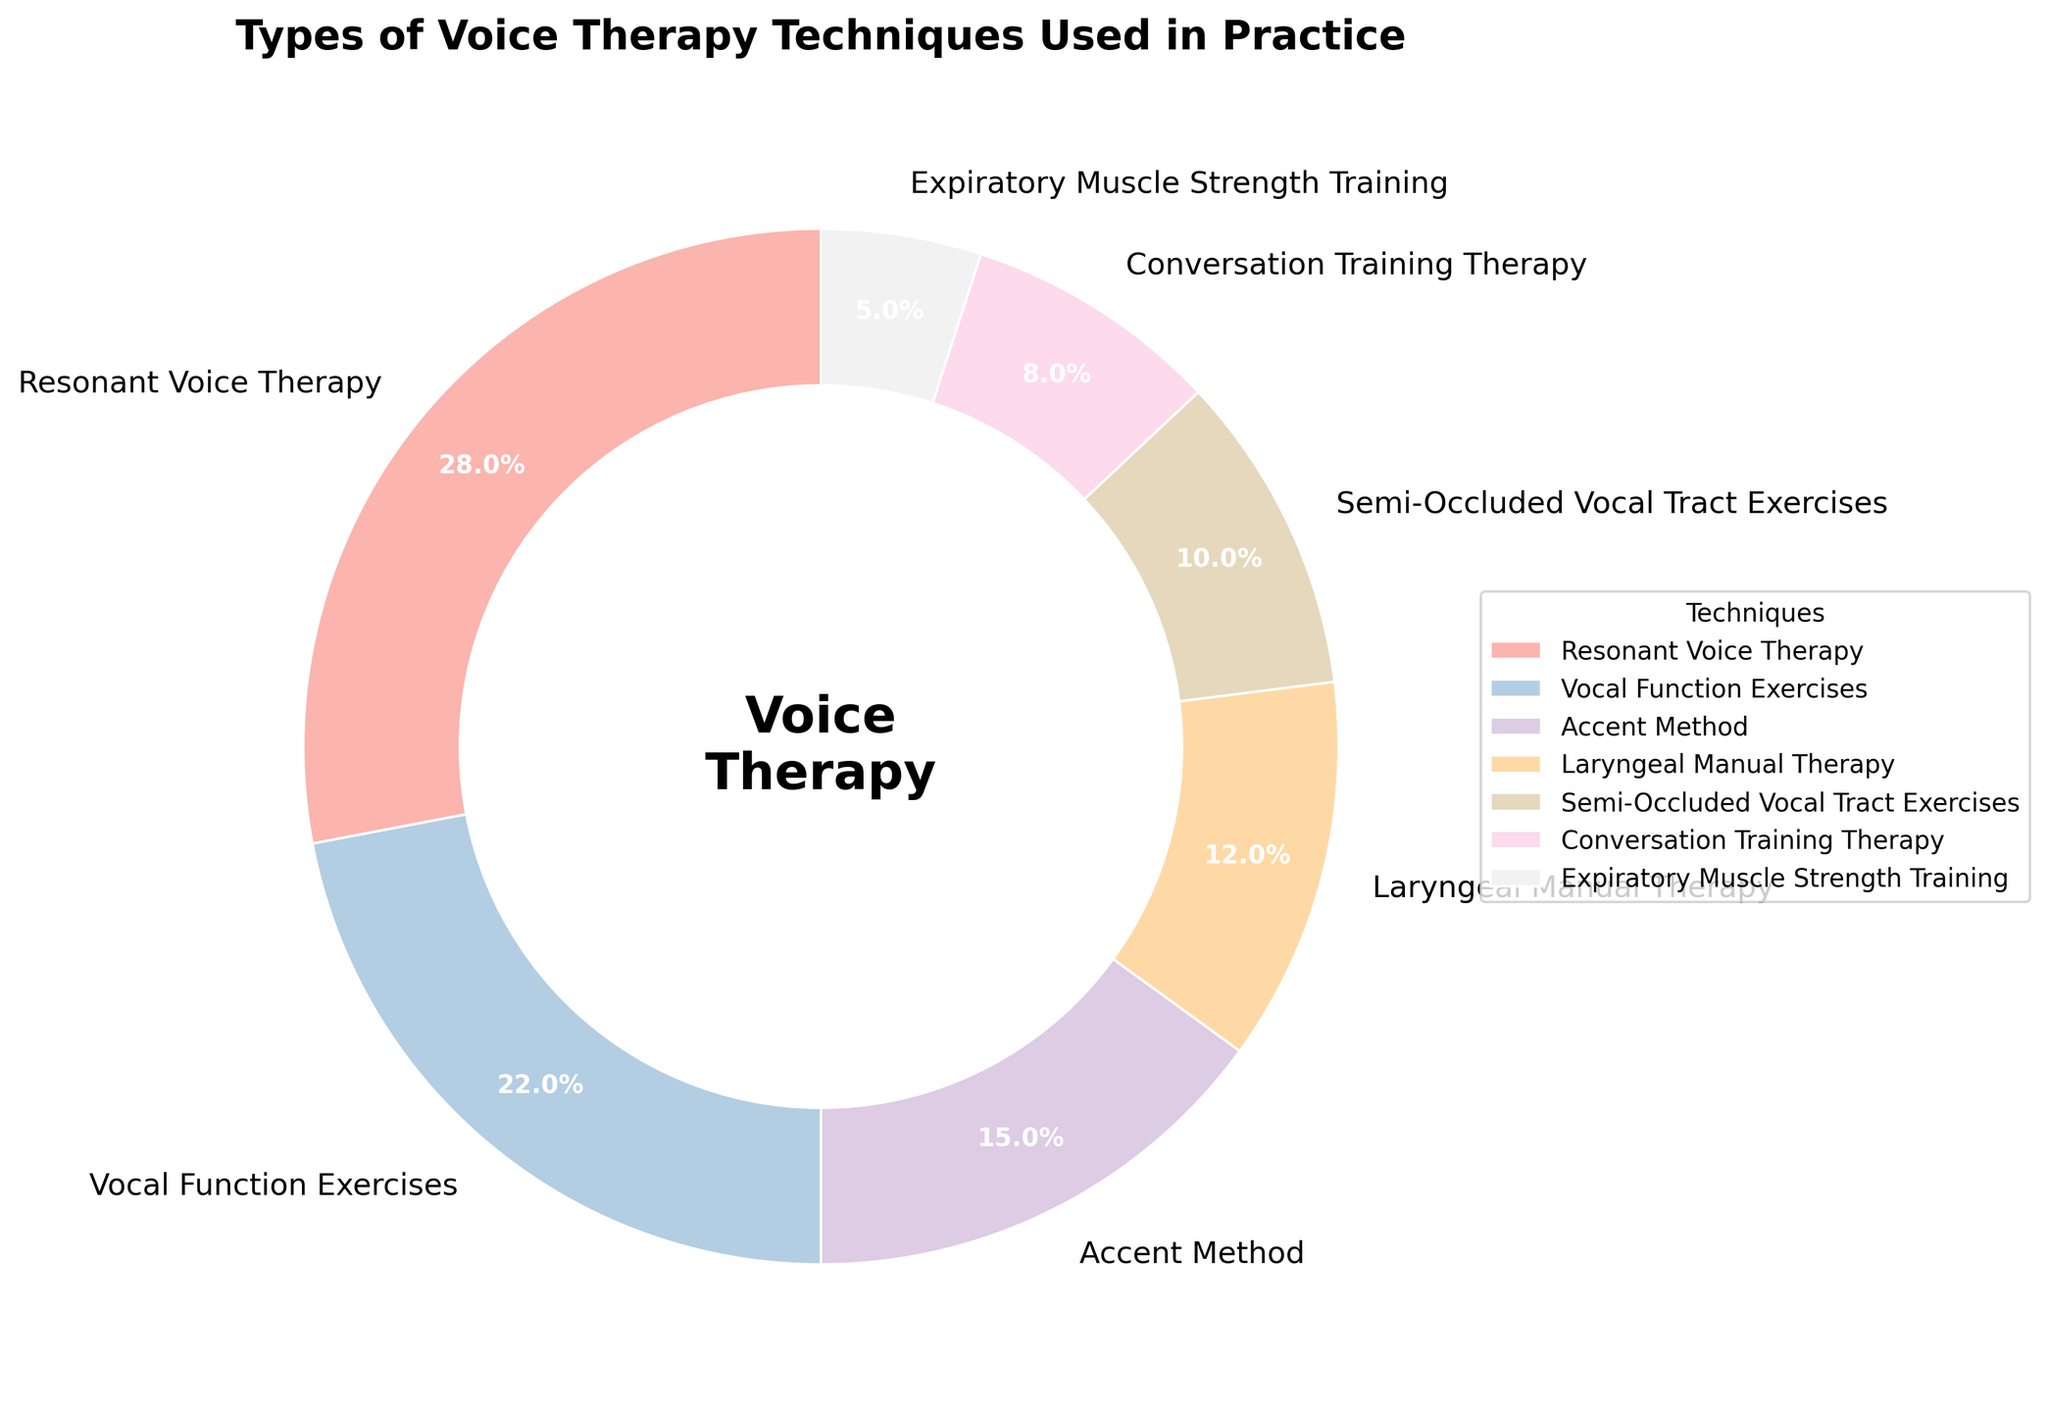What percentage of the techniques are accounted for by "Resonant Voice Therapy" and "Vocal Function Exercises" combined? "Resonant Voice Therapy" and "Vocal Function Exercises" are 28% and 22%, respectively. Summing these gives 28% + 22% = 50%.
Answer: 50% Which technique has the lowest percentage in the pie chart? By visually inspecting the slices, "Expiratory Muscle Strength Training" has the smallest slice. According to the data, its percentage is 5%.
Answer: Expiratory Muscle Strength Training Is the percentage for "Accent Method" greater than that for "Laryngeal Manual Therapy"? Comparing the slices visually, "Accent Method" (15%) is greater than "Laryngeal Manual Therapy" (12%).
Answer: Yes How much more common is "Semi-Occluded Vocal Tract Exercises" compared to "Expiratory Muscle Strength Training"? "Semi-Occluded Vocal Tract Exercises" is 10% and "Expiratory Muscle Strength Training" is 5%. Subtracting these percentages gives 10% - 5% = 5%.
Answer: 5% What is the approximate combined percentage of the three least common techniques? The three least common techniques are "Expiratory Muscle Strength Training" (5%), "Conversation Training Therapy" (8%), and "Semi-Occluded Vocal Tract Exercises" (10%). Adding these up gives 5% + 8% + 10% = 23%.
Answer: 23% Which technique occupies the largest portion of the pie chart? Visually, the largest slice belongs to "Resonant Voice Therapy," which is 28%.
Answer: Resonant Voice Therapy Compare the summed percentage of "Accent Method" and "Laryngeal Manual Therapy" to "Resonant Voice Therapy." "Accent Method" is 15% and "Laryngeal Manual Therapy" is 12%. Summing these gives 15% + 12% = 27%. "Resonant Voice Therapy" alone is 28%.
Answer: Less Is the section representing "Vocal Function Exercises" larger than that for "Accent Method"? "Vocal Function Exercises" takes up 22% while "Accent Method" takes up 15%, making "Vocal Function Exercises" larger.
Answer: Yes 